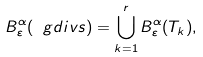Convert formula to latex. <formula><loc_0><loc_0><loc_500><loc_500>B _ { \varepsilon } ^ { \alpha } ( \ g d i v s ) = \bigcup _ { k = 1 } ^ { r } B _ { \varepsilon } ^ { \alpha } ( T _ { k } ) ,</formula> 